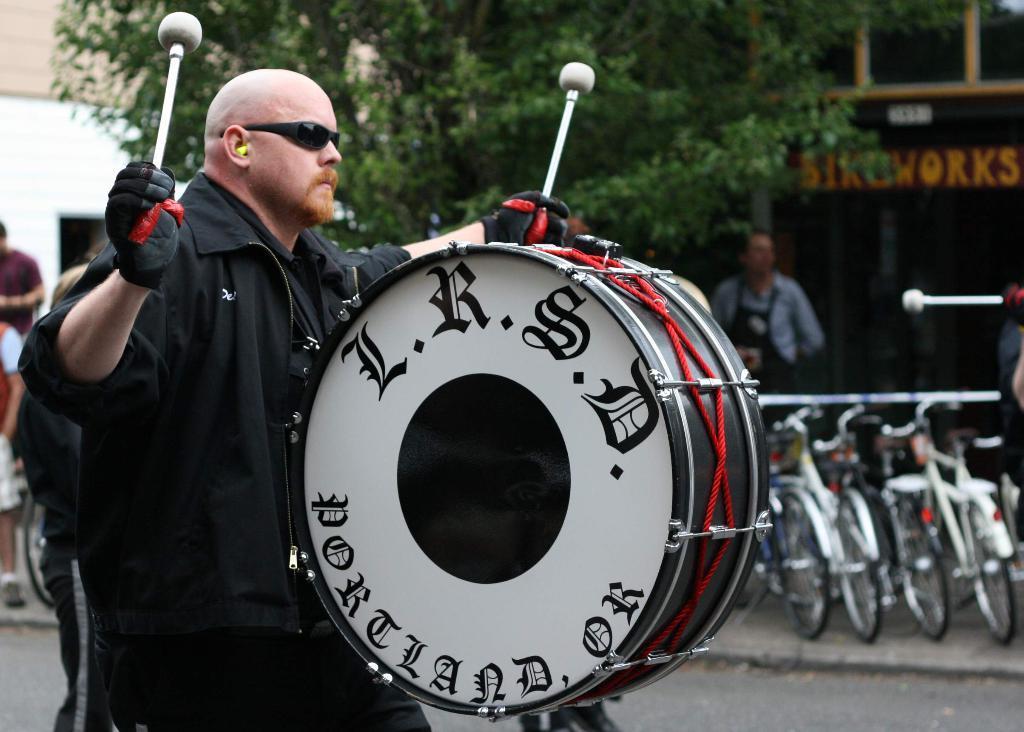Could you give a brief overview of what you see in this image? In this picture man in the center is holding a drum and is playing drums. In the background there are four cycles, and a man is standing, there are trees and a building. At the left side there are two persons standing. 